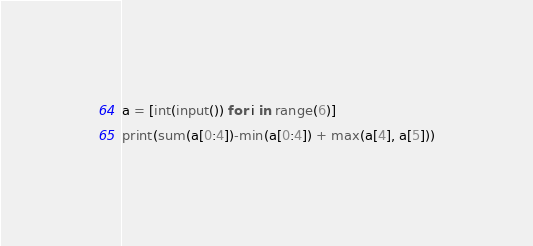<code> <loc_0><loc_0><loc_500><loc_500><_Python_>a = [int(input()) for i in range(6)]
print(sum(a[0:4])-min(a[0:4]) + max(a[4], a[5]))
</code> 